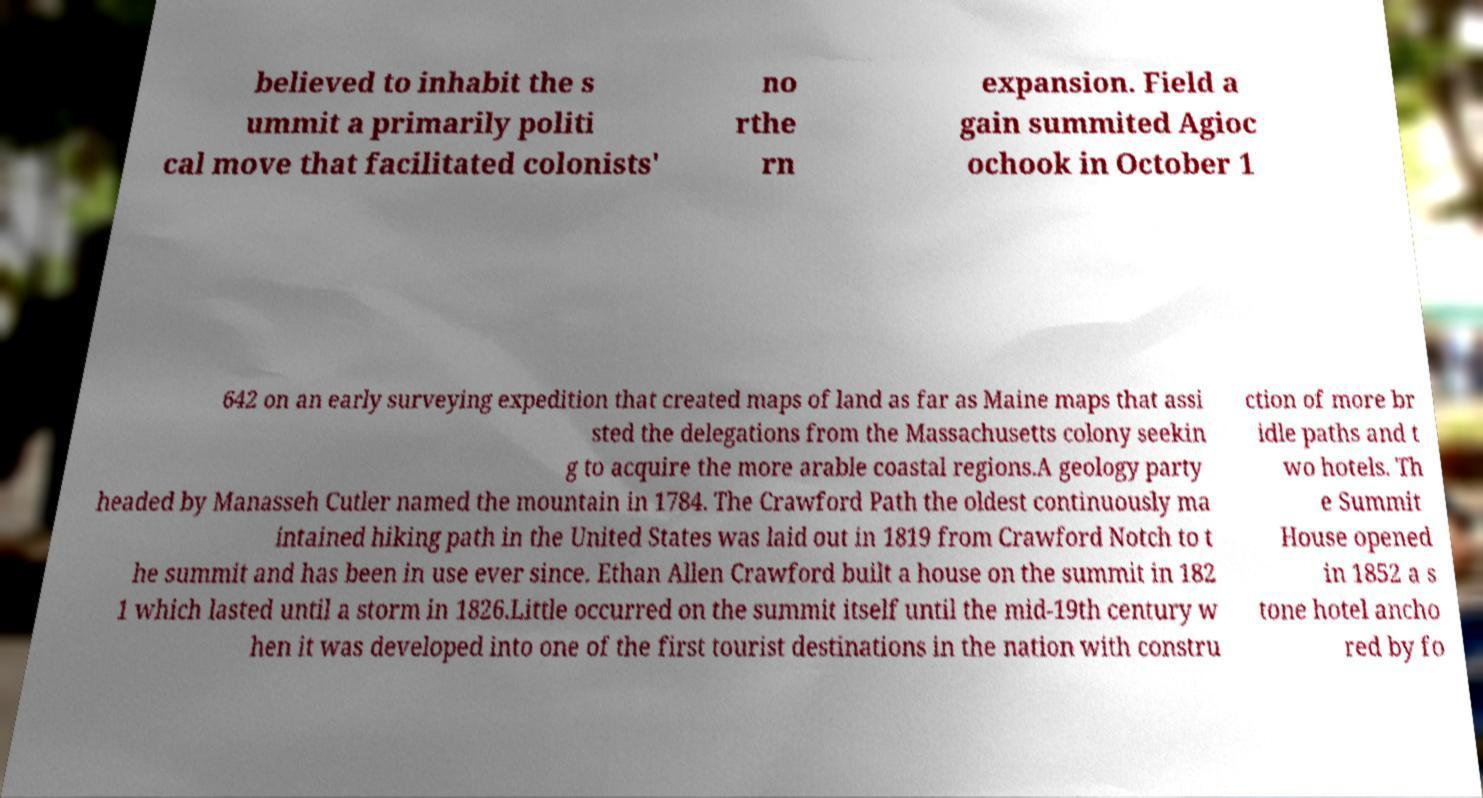There's text embedded in this image that I need extracted. Can you transcribe it verbatim? believed to inhabit the s ummit a primarily politi cal move that facilitated colonists' no rthe rn expansion. Field a gain summited Agioc ochook in October 1 642 on an early surveying expedition that created maps of land as far as Maine maps that assi sted the delegations from the Massachusetts colony seekin g to acquire the more arable coastal regions.A geology party headed by Manasseh Cutler named the mountain in 1784. The Crawford Path the oldest continuously ma intained hiking path in the United States was laid out in 1819 from Crawford Notch to t he summit and has been in use ever since. Ethan Allen Crawford built a house on the summit in 182 1 which lasted until a storm in 1826.Little occurred on the summit itself until the mid-19th century w hen it was developed into one of the first tourist destinations in the nation with constru ction of more br idle paths and t wo hotels. Th e Summit House opened in 1852 a s tone hotel ancho red by fo 